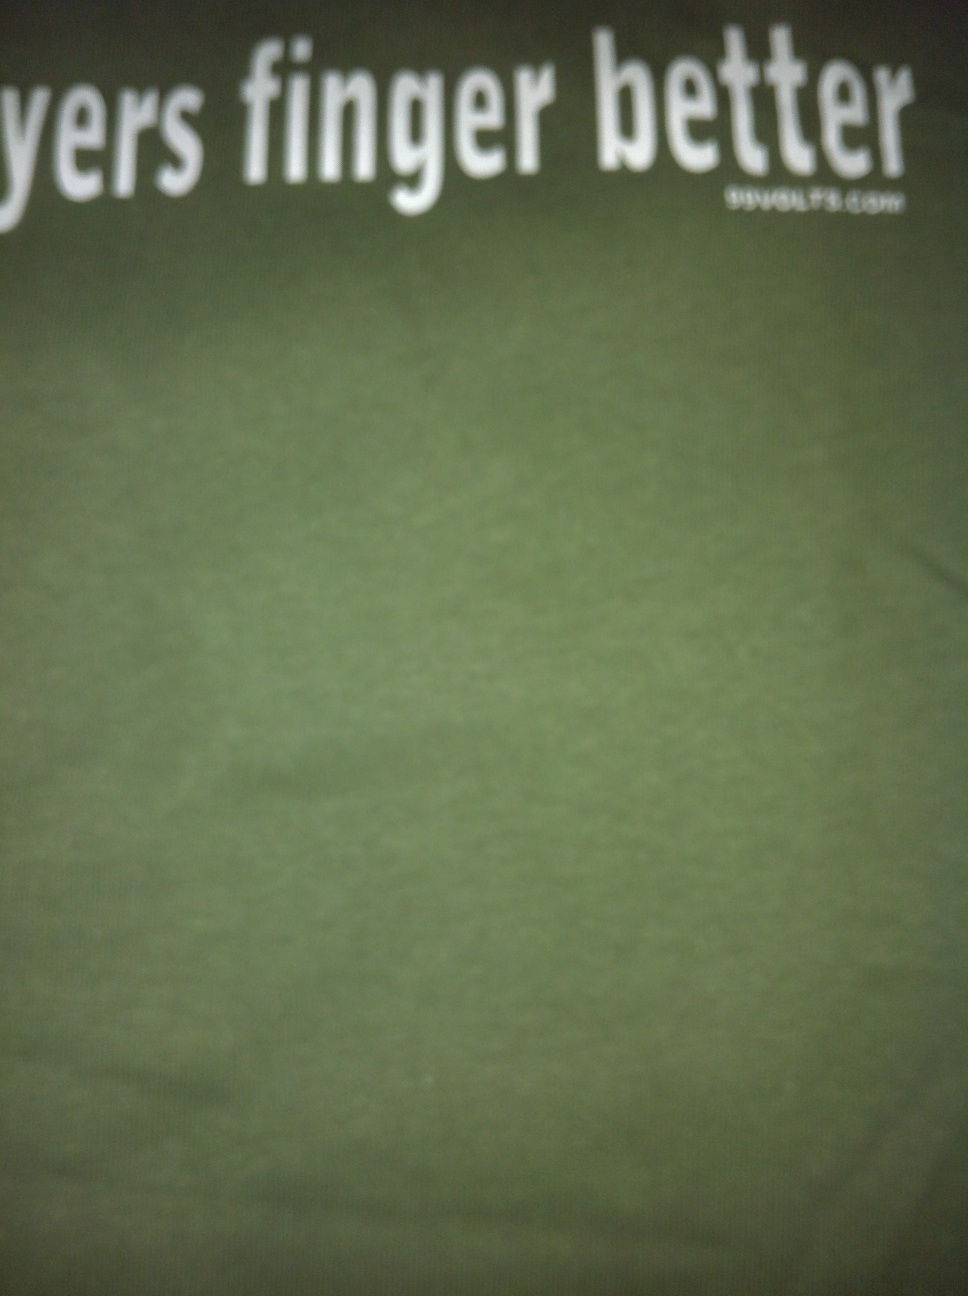Could you please describe this shirt as best as possible? I know it's a t-shirt, but I don't know what kind it is. This is a dark green t-shirt featuring a humorous phrase 'players finger better' in bold white letters. The text style is simple, using a clean sans-serif font that suggests a modern and casual look. The shirt itself appears to be of a standard fit, potentially made from a cotton blend, which makes it suitable for casual wear. Its brand and specific fabric type are not visible, but its design seems targeted towards young adults with an interest in music or gaming phrases, judging by the playful message. 